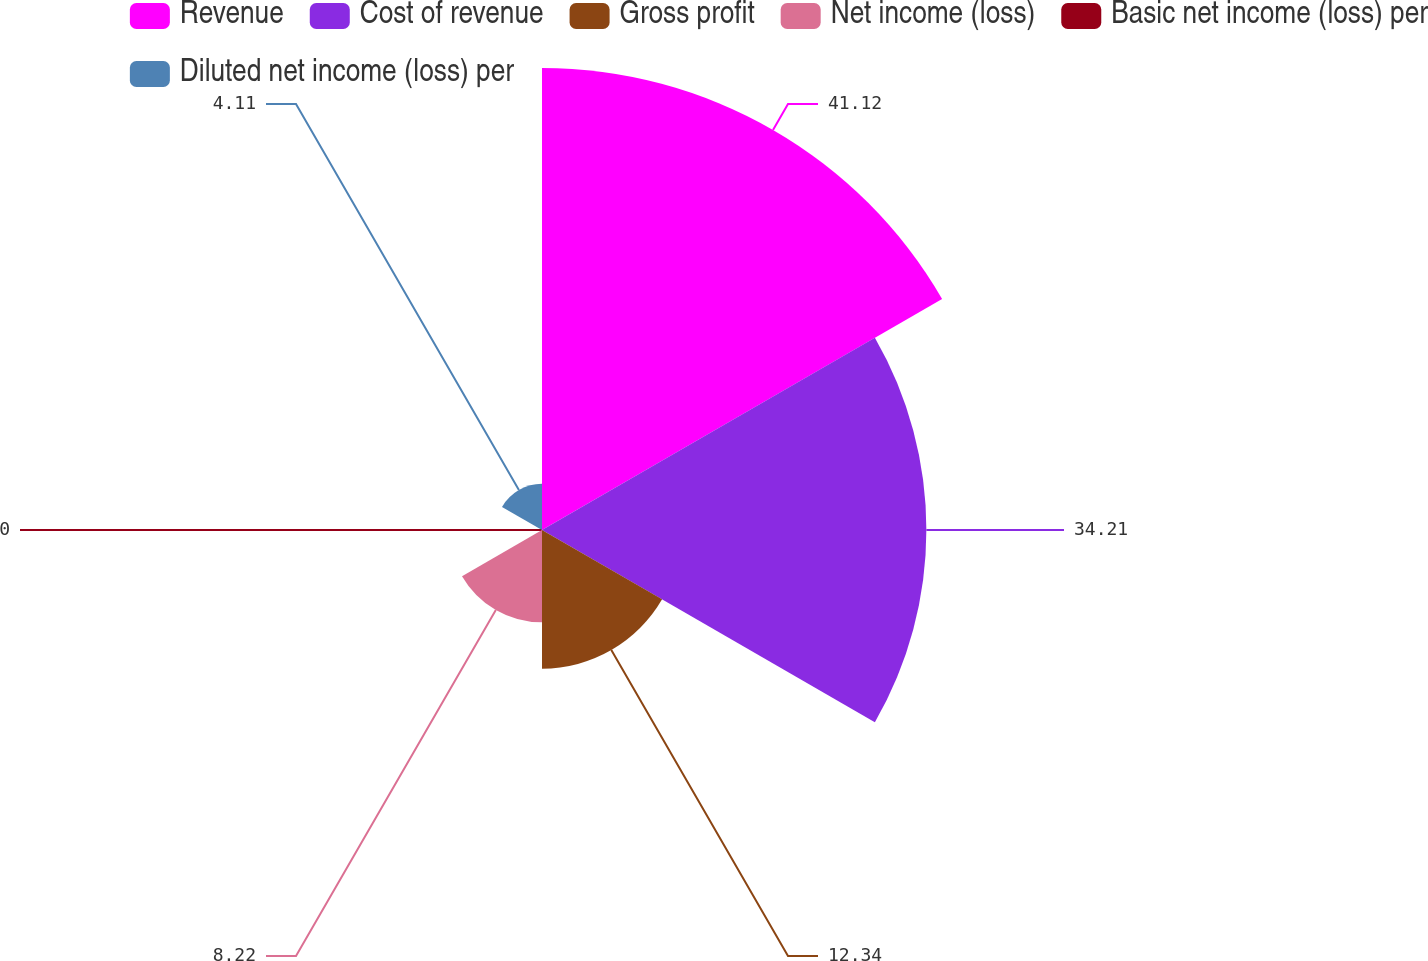Convert chart to OTSL. <chart><loc_0><loc_0><loc_500><loc_500><pie_chart><fcel>Revenue<fcel>Cost of revenue<fcel>Gross profit<fcel>Net income (loss)<fcel>Basic net income (loss) per<fcel>Diluted net income (loss) per<nl><fcel>41.12%<fcel>34.21%<fcel>12.34%<fcel>8.22%<fcel>0.0%<fcel>4.11%<nl></chart> 